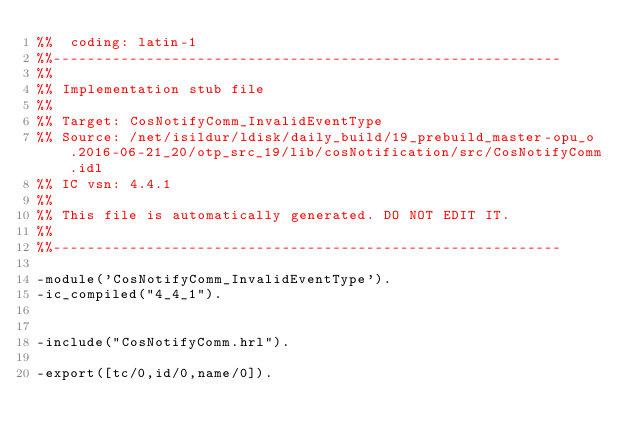Convert code to text. <code><loc_0><loc_0><loc_500><loc_500><_Erlang_>%%  coding: latin-1
%%------------------------------------------------------------
%%
%% Implementation stub file
%% 
%% Target: CosNotifyComm_InvalidEventType
%% Source: /net/isildur/ldisk/daily_build/19_prebuild_master-opu_o.2016-06-21_20/otp_src_19/lib/cosNotification/src/CosNotifyComm.idl
%% IC vsn: 4.4.1
%% 
%% This file is automatically generated. DO NOT EDIT IT.
%%
%%------------------------------------------------------------

-module('CosNotifyComm_InvalidEventType').
-ic_compiled("4_4_1").


-include("CosNotifyComm.hrl").

-export([tc/0,id/0,name/0]).


</code> 